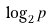Convert formula to latex. <formula><loc_0><loc_0><loc_500><loc_500>\log _ { 2 } p</formula> 